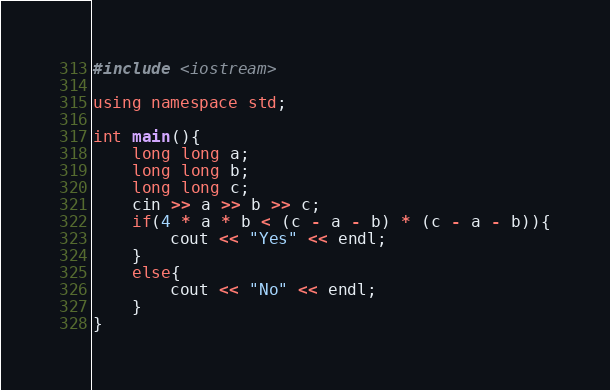<code> <loc_0><loc_0><loc_500><loc_500><_C++_>#include <iostream>

using namespace std;

int main(){
    long long a;
    long long b;
    long long c;
    cin >> a >> b >> c;
    if(4 * a * b < (c - a - b) * (c - a - b)){
        cout << "Yes" << endl;
    }
    else{
        cout << "No" << endl;
    }
}</code> 